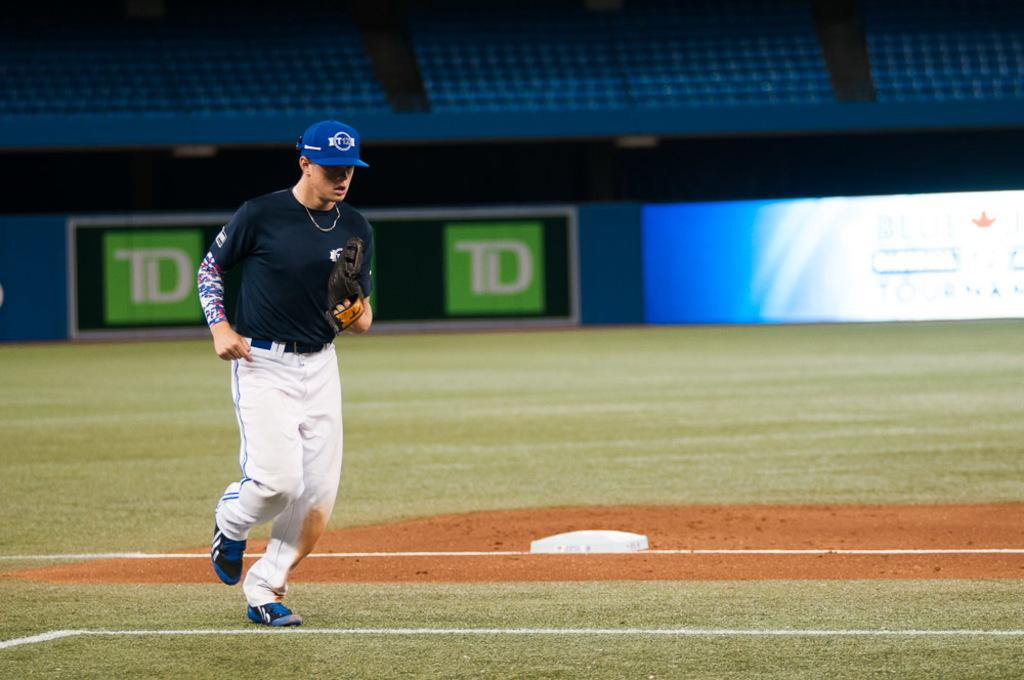<image>
Write a terse but informative summary of the picture. Man standing in a baseball field with the letters TD in the back. 